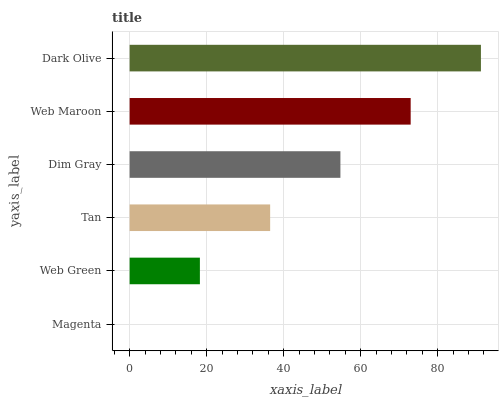Is Magenta the minimum?
Answer yes or no. Yes. Is Dark Olive the maximum?
Answer yes or no. Yes. Is Web Green the minimum?
Answer yes or no. No. Is Web Green the maximum?
Answer yes or no. No. Is Web Green greater than Magenta?
Answer yes or no. Yes. Is Magenta less than Web Green?
Answer yes or no. Yes. Is Magenta greater than Web Green?
Answer yes or no. No. Is Web Green less than Magenta?
Answer yes or no. No. Is Dim Gray the high median?
Answer yes or no. Yes. Is Tan the low median?
Answer yes or no. Yes. Is Dark Olive the high median?
Answer yes or no. No. Is Dim Gray the low median?
Answer yes or no. No. 